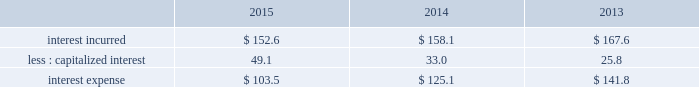Business separation costs on 16 september 2015 , the company announced that it intends to separate its materials technologies business via a spin-off .
During the fourth quarter , we incurred legal and other advisory fees of $ 7.5 ( $ .03 per share ) .
Gain on previously held equity interest on 30 december 2014 , we acquired our partner 2019s equity ownership interest in a liquefied atmospheric industrial gases production joint venture in north america for $ 22.6 which increased our ownership from 50% ( 50 % ) to 100% ( 100 % ) .
The transaction was accounted for as a business combination , and subsequent to the acquisition , the results are consolidated within our industrial gases 2013 americas segment .
The assets acquired , primarily plant and equipment , were recorded at their fair value as of the acquisition date .
The acquisition date fair value of the previously held equity interest was determined using a discounted cash flow analysis under the income approach .
During the first quarter of 2015 , we recorded a gain of $ 17.9 ( $ 11.2 after-tax , or $ .05 per share ) as a result of revaluing our previously held equity interest to fair value as of the acquisition date .
Advisory costs during the fourth quarter of 2013 , we incurred legal and other advisory fees of $ 10.1 ( $ 6.4 after-tax , or $ .03 per share ) in connection with our response to the rapid acquisition of a large position in shares of our common stock by pershing square capital management llc and its affiliates .
Other income ( expense ) , net items recorded to other income ( expense ) , net arise from transactions and events not directly related to our principal income earning activities .
The detail of other income ( expense ) , net is presented in note 24 , supplemental information , to the consolidated financial statements .
2015 vs .
2014 other income ( expense ) , net of $ 47.3 decreased $ 5.5 .
The current year includes a gain of $ 33.6 ( $ 28.3 after-tax , or $ .13 per share ) resulting from the sale of two parcels of land .
The gain was partially offset by unfavorable foreign exchange impacts and lower gains on other sales of assets and emissions credits .
No other individual items were significant in comparison to the prior year .
2014 vs .
2013 other income ( expense ) , net of $ 52.8 decreased $ 17.4 , primarily due to higher gains from the sale of a number of small assets and investments , higher government grants , and a favorable commercial contract settlement in 2013 .
Otherwise , no individual items were significant in comparison to 2013 .
Interest expense .
2015 vs .
2014 interest incurred decreased $ 5.5 .
The decrease was driven by the impact of a stronger u.s .
Dollar on the translation of foreign currency interest of $ 12 , partially offset by a higher average debt balance of $ 7 .
The change in capitalized interest was driven by a higher carrying value in construction in progress .
2014 vs .
2013 interest incurred decreased $ 9.5 .
The decrease was primarily due to a lower average interest rate on the debt portfolio which reduced interest by $ 13 , partially offset by a higher average debt balance which increased interest by $ 6 .
The change in capitalized interest was driven by a higher carrying value in construction in progress .
Loss on early retirement of debt in september 2015 , we made a payment of $ 146.6 to redeem 3000000 unidades de fomento ( 201cuf 201d ) series e 6.30% ( 6.30 % ) bonds due 22 january 2030 that had a carrying value of $ 130.0 and resulted in a net loss of $ 16.6 ( $ 14.2 after-tax , or $ .07 per share ) . .
Considering the years 2013-2015 , what is the highest value of interest incurred? 
Rationale: it is the maximum value of interest incurred .
Computations: table_max(interest incurred, none)
Answer: 167.6. 